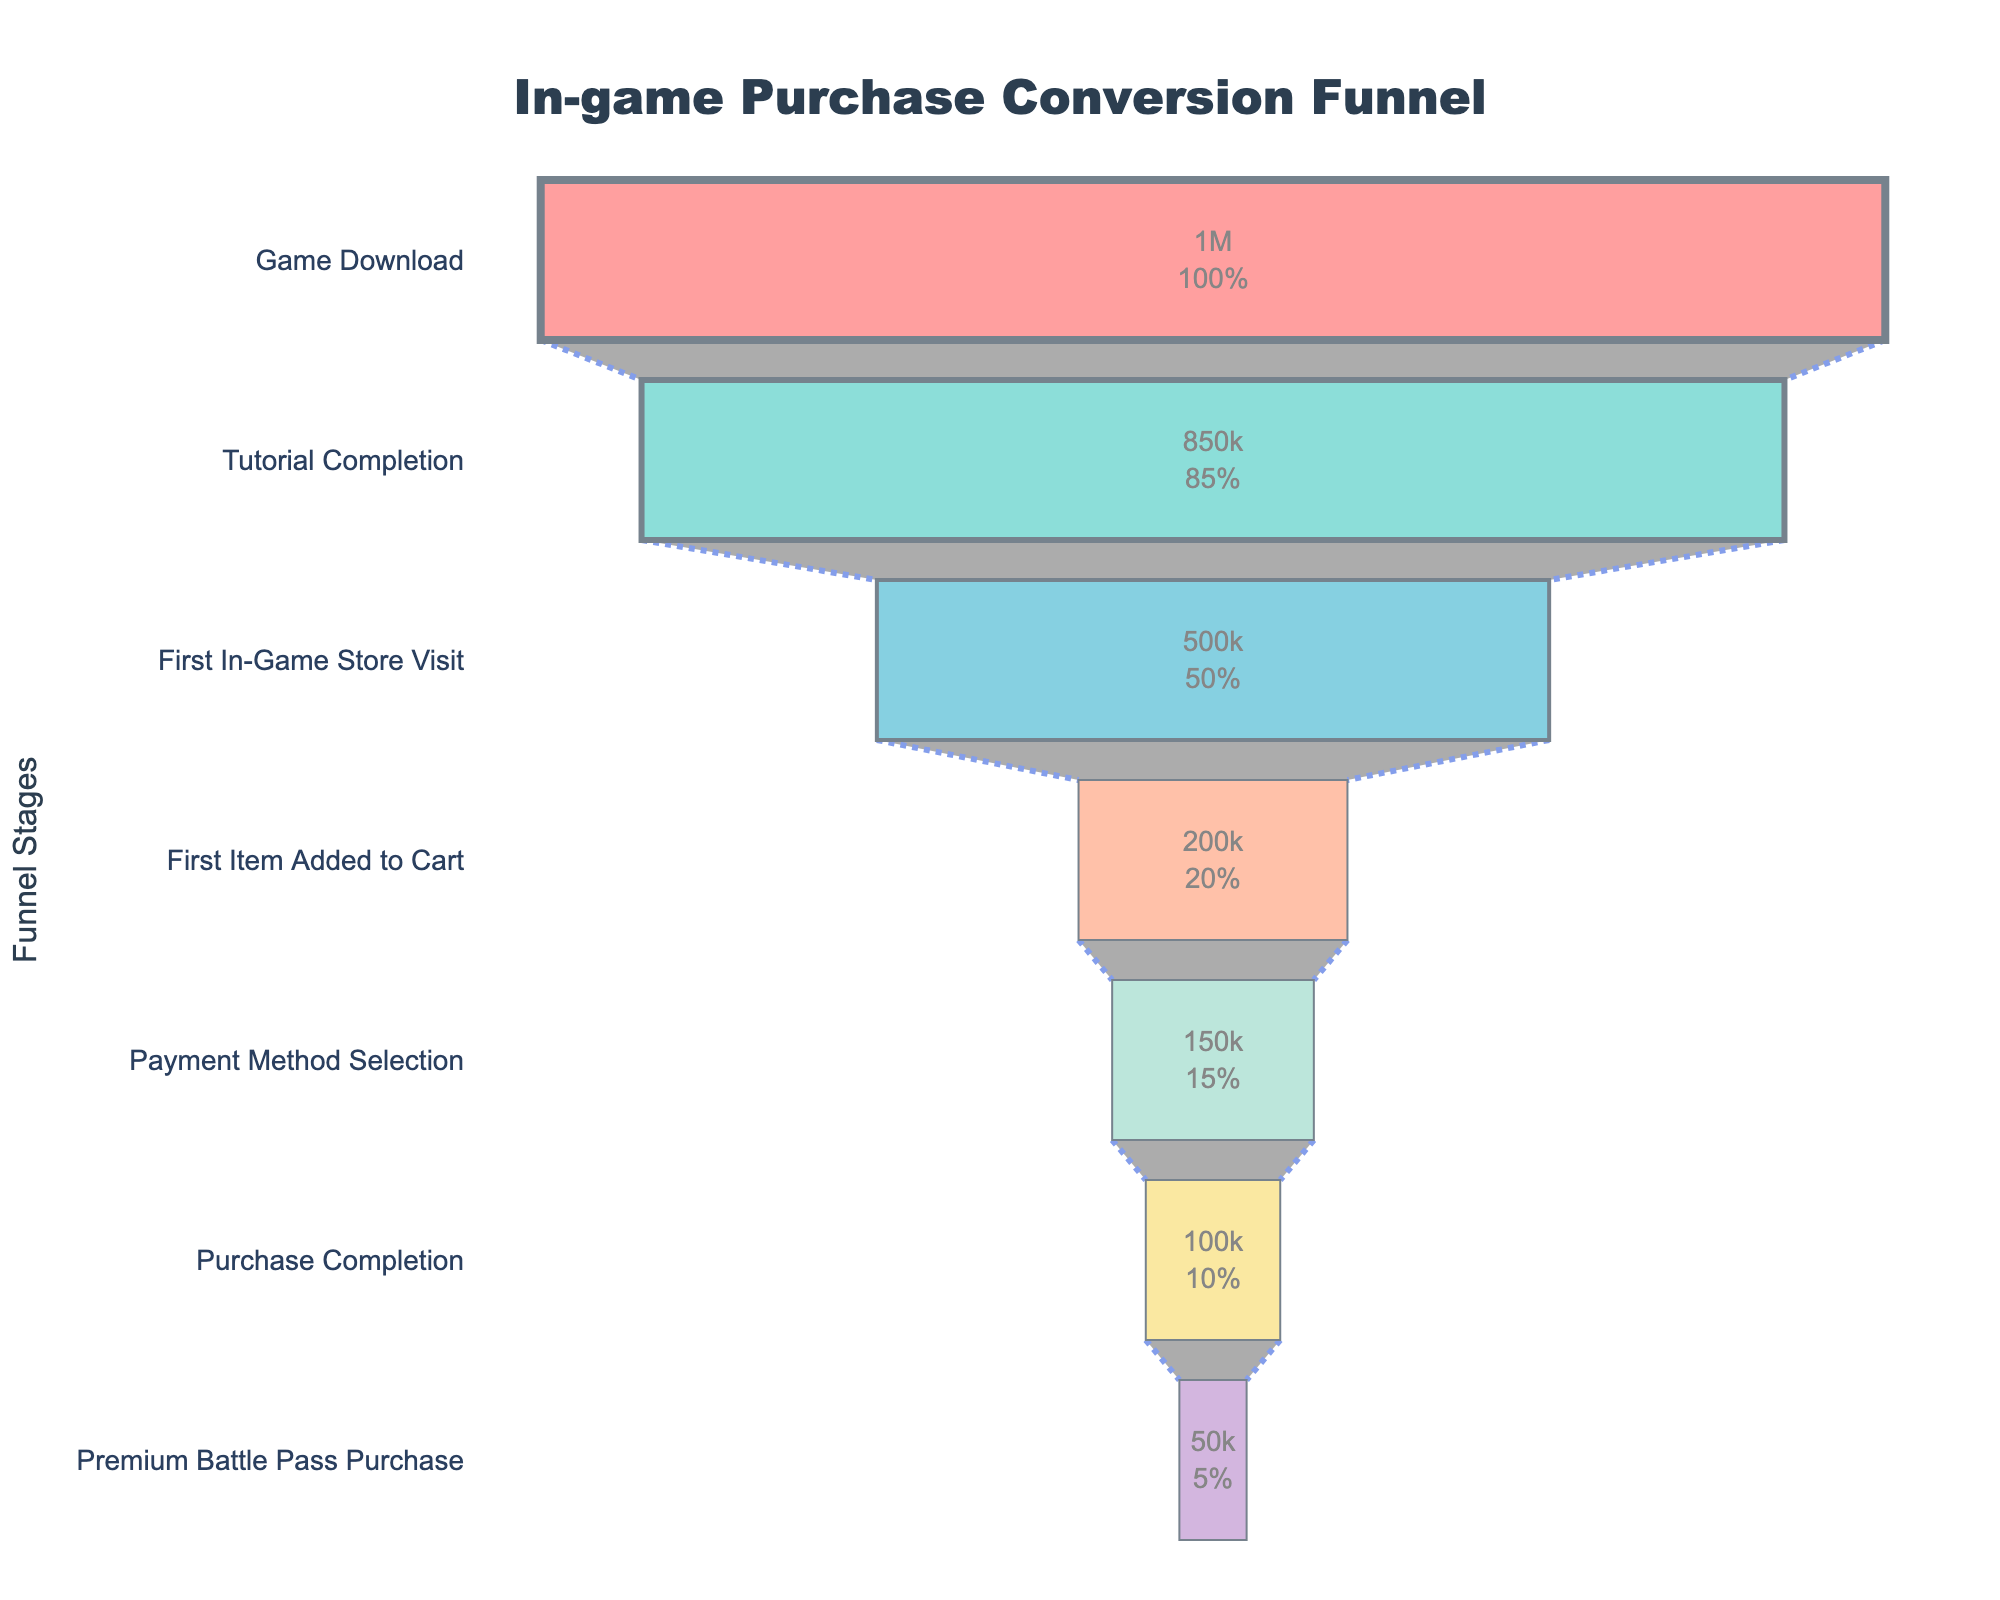What's the title of the funnel chart? The title of the funnel chart is positioned at the top, typically in a larger and bold font to stand out. It reads "In-game Purchase Conversion Funnel".
Answer: In-game Purchase Conversion Funnel Which stage in the funnel has the highest number of users? By looking at the funnel chart, the widest part at the top represents the stage "Game Download" which has the highest number of users.
Answer: Game Download How many users completed the tutorial relative to those who downloaded the game? To determine the number of users who completed the tutorial relative to the game downloads, look at the first two stages. 850,000 users completed the tutorial out of 1,000,000 who downloaded the game.
Answer: 850,000 What percentage of users added their first item to the cart after visiting the in-game store? To find this percentage, divide the users who added an item to the cart (200,000) by those who visited the in-game store (500,000), then multiply by 100. This is (200,000 / 500,000) * 100 = 40%.
Answer: 40% How many steps are there in the funnel from "Game Download" to "Premium Battle Pass Purchase"? By counting the different stages in the funnel from "Game Download" at the top to "Premium Battle Pass Purchase" at the bottom, there are seven steps.
Answer: 7 What is the drop-off number from tutorial completion to the first in-game store visit? The drop-off number can be calculated by subtracting the number of users at "First In-Game Store Visit" (500,000) from the number at "Tutorial Completion" (850,000). This is 850,000 - 500,000 = 350,000 users.
Answer: 350,000 Which stage shows the most significant drop in users compared to the previous stage? The most significant drop can be observed between "Tutorial Completion" and "First In-Game Store Visit", where the number of users drops from 850,000 to 500,000.
Answer: From Tutorial Completion to First In-Game Store Visit How does the number of users selecting a payment method compare to those completing a purchase? The stage "Payment Method Selection" has 150,000 users, and "Purchase Completion" has 100,000 users. Comparing these, 150,000 - 100,000 = 50,000 more users selected a payment method than completed a purchase.
Answer: 50,000 more What's the percent drop from the first item added to the cart to payment method selection? To calculate this percentage drop, subtract the users at "Payment Method Selection" (150,000) from those at "First Item Added to Cart" (200,000), then divide by 200,000 and multiply by 100. This is (200,000 - 150,000) / 200,000 * 100 = 25%.
Answer: 25% What fraction of users downloaded the game but did not complete the tutorial? Subtract users who completed the tutorial (850,000) from those who downloaded the game (1,000,000), giving 150,000 users. The fraction is 150,000 / 1,000,000 = 3/20 or 0.15.
Answer: 0.15 